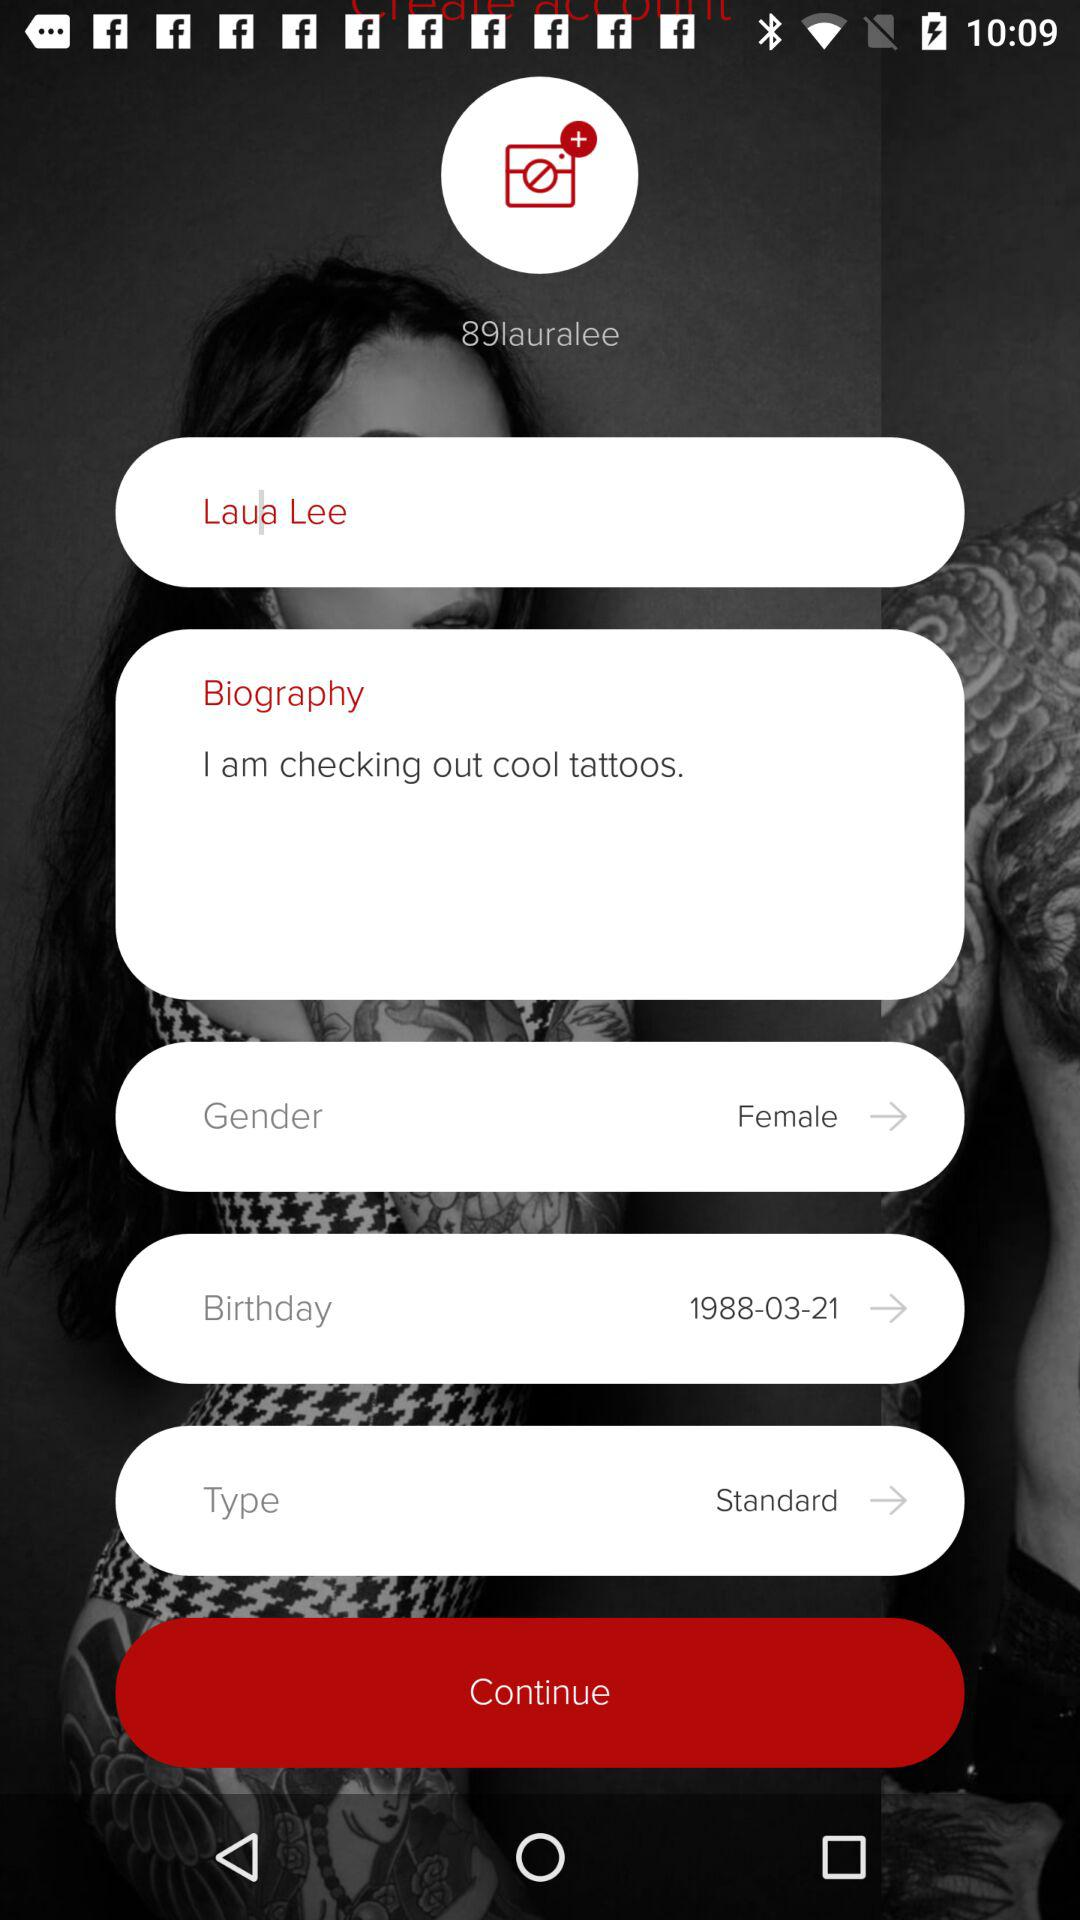What is the gender? The gender is female. 